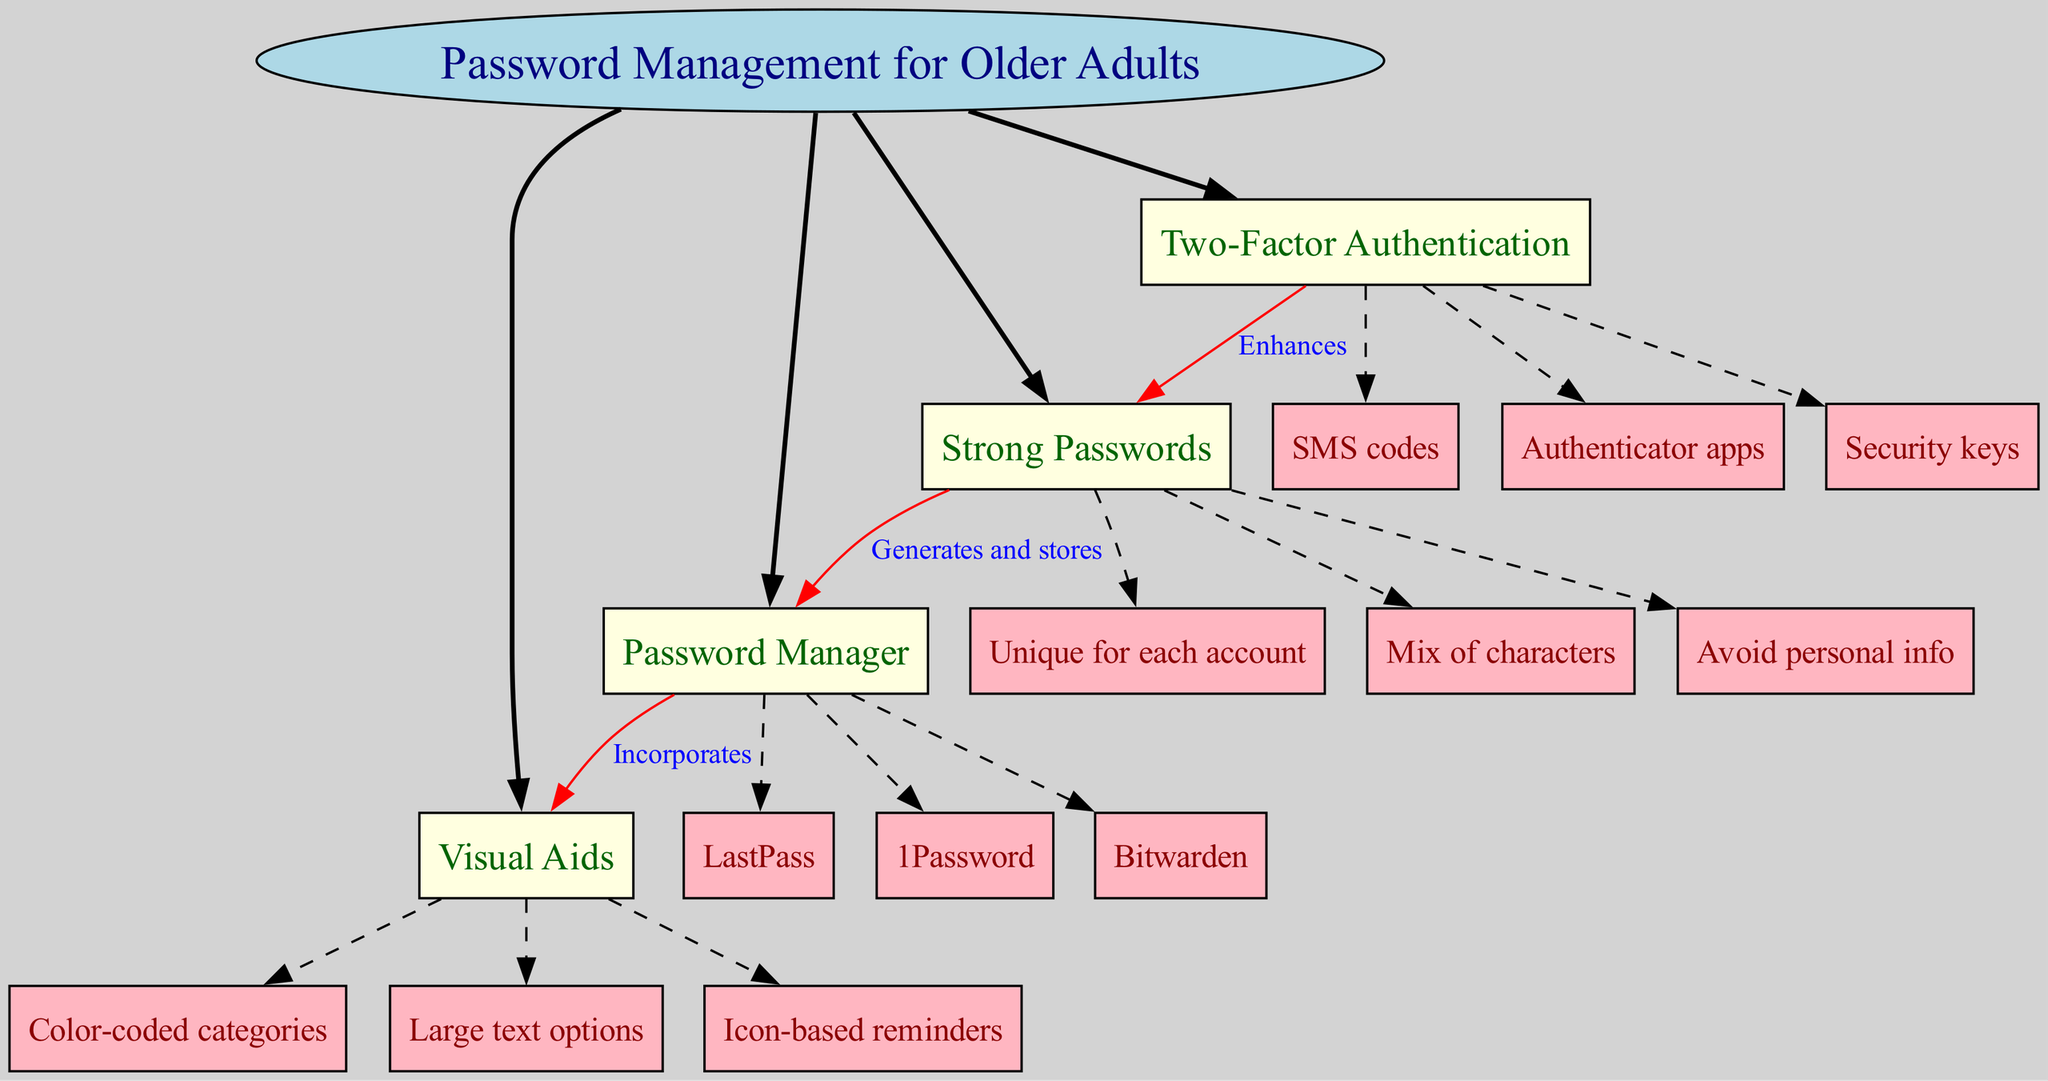What are the four main nodes in the diagram? The diagram contains four main nodes: Strong Passwords, Password Manager, Two-Factor Authentication, and Visual Aids. These nodes radiate from the central concept, indicating key themes in password management.
Answer: Strong Passwords, Password Manager, Two-Factor Authentication, Visual Aids Which sub-node is associated with Strong Passwords that denotes avoiding easily obtainable information? The sub-node related to avoiding personal information for Strong Passwords signifies that individuals should refrain from using information that can be easily guessed or obtained. This is a crucial part of creating strong passwords.
Answer: Avoid personal info How many sub-nodes does the Password Manager have? The Password Manager has three sub-nodes: LastPass, 1Password, and Bitwarden. These sub-nodes represent different tools available for managing passwords securely.
Answer: 3 What enhances Strong Passwords according to the diagram? Two-Factor Authentication enhances Strong Passwords, as it adds an additional layer of security. This means that even if a password is compromised, the account remains protected by requiring a second verification step.
Answer: Two-Factor Authentication What kind of visual aids does the Password Manager incorporate? The Password Manager incorporates Visual Aids such as color-coded categories, large text options, and icon-based reminders. These features support older adults in managing their passwords more effectively through improved visibility and organization.
Answer: Visual Aids What is the relationship between Strong Passwords and Password Manager? The relationship is labeled as "Generates and stores," indicating that strong passwords are not only created but also stored within the password manager for safety and convenience. This highlights the functionality of a password manager in securing information.
Answer: Generates and stores How many connections are shown in the diagram? There are three connections in the diagram. These connections illustrate the relationships between the different main nodes, emphasizing how concepts in password management interconnect to enhance security practices.
Answer: 3 What visual aid type uses large text options? The large text options are part of the Visual Aids strategy, which aims to assist older adults in viewing and remembering their password management information more easily. This answer highlights a specific type of visual support intended for better accessibility.
Answer: Large text options 